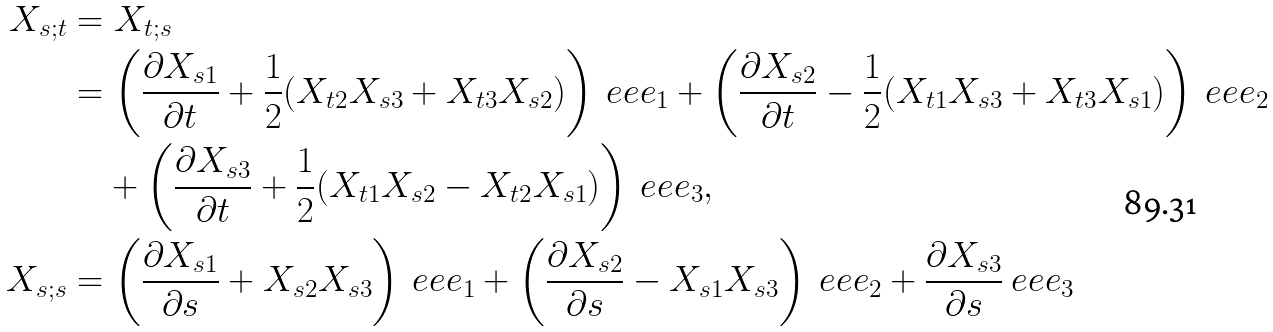<formula> <loc_0><loc_0><loc_500><loc_500>X _ { s ; t } & = X _ { t ; s } \\ & = \left ( \frac { \partial X _ { s 1 } } { \partial t } + \frac { 1 } { 2 } ( X _ { t 2 } X _ { s 3 } + X _ { t 3 } X _ { s 2 } ) \right ) \ e e e _ { 1 } + \left ( \frac { \partial X _ { s 2 } } { \partial t } - \frac { 1 } { 2 } ( X _ { t 1 } X _ { s 3 } + X _ { t 3 } X _ { s 1 } ) \right ) \ e e e _ { 2 } \\ & \quad + \left ( \frac { \partial X _ { s 3 } } { \partial t } + \frac { 1 } { 2 } ( X _ { t 1 } X _ { s 2 } - X _ { t 2 } X _ { s 1 } ) \right ) \ e e e _ { 3 } , \\ X _ { s ; s } & = \left ( \frac { \partial X _ { s 1 } } { \partial s } + X _ { s 2 } X _ { s 3 } \right ) \ e e e _ { 1 } + \left ( \frac { \partial X _ { s 2 } } { \partial s } - X _ { s 1 } X _ { s 3 } \right ) \ e e e _ { 2 } + \frac { \partial X _ { s 3 } } { \partial s } \ e e e _ { 3 }</formula> 